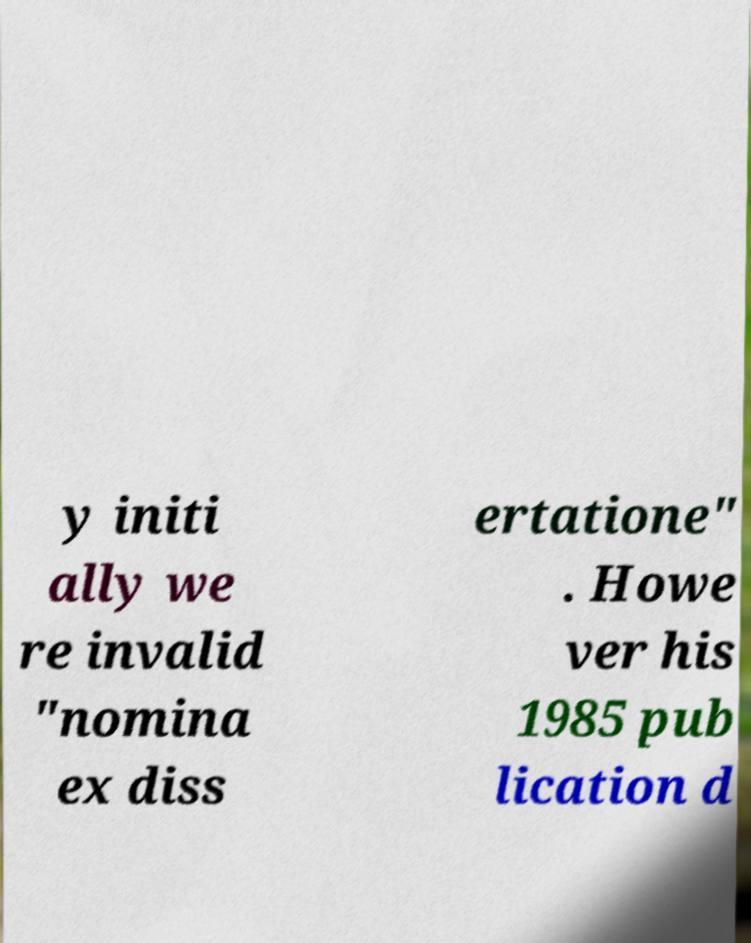What messages or text are displayed in this image? I need them in a readable, typed format. y initi ally we re invalid "nomina ex diss ertatione" . Howe ver his 1985 pub lication d 